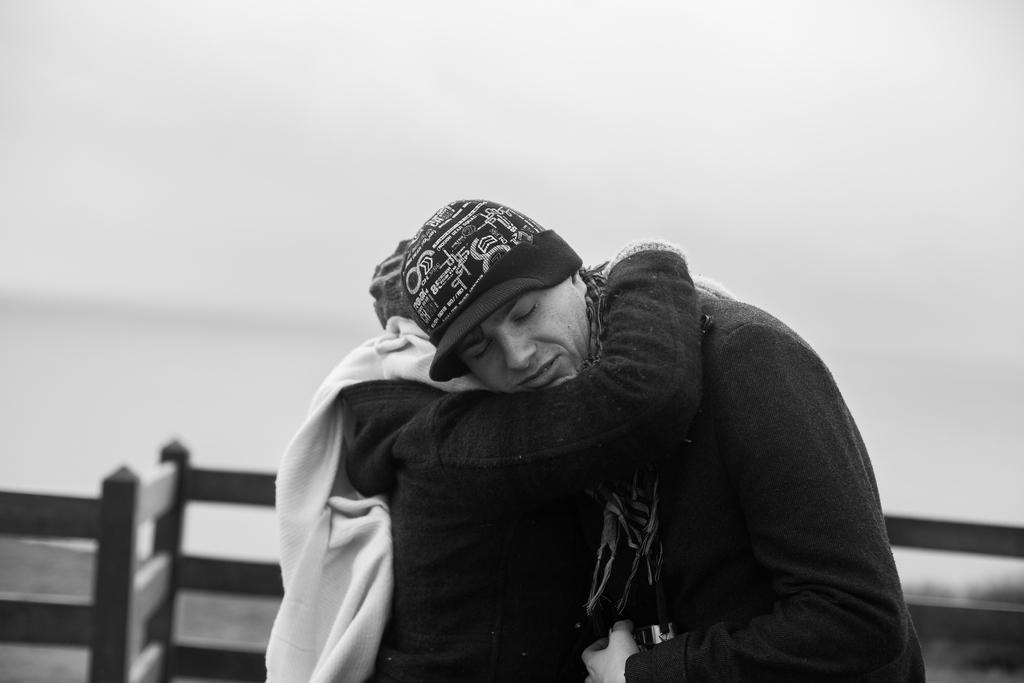Please provide a concise description of this image. In this picture I can observe two members in the middle of the picture. Behind them I can observe a railing. This is a black and white image. 